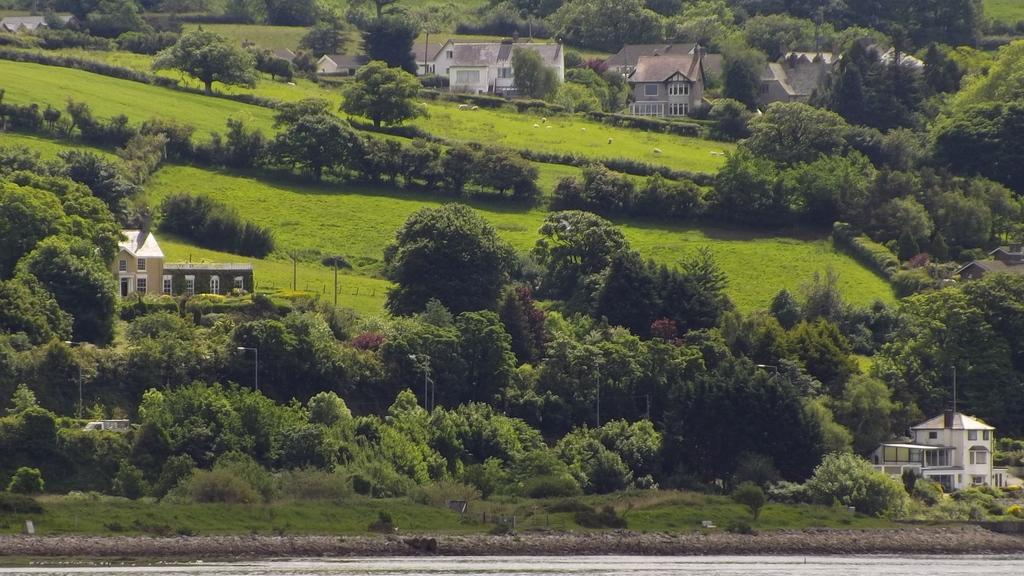What type of structures can be seen in the image? There are buildings in the image. What is the environment like around the buildings? The buildings are surrounded by trees. What else can be seen in the image besides the buildings and trees? There are animals in the image. What are the animals doing in the image? The animals are eating grass. Where is the grass located in the image? The grass is located in the middle of the image. What color is the knot tied by the pigs in the image? There are no pigs or knots present in the image. 